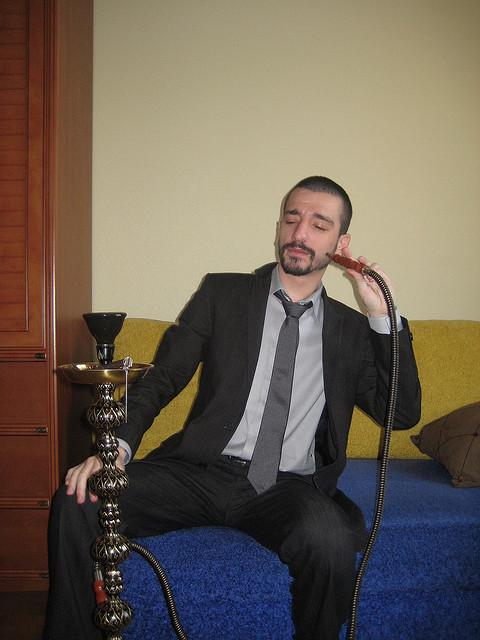What comes through the pipe held here? smoke 